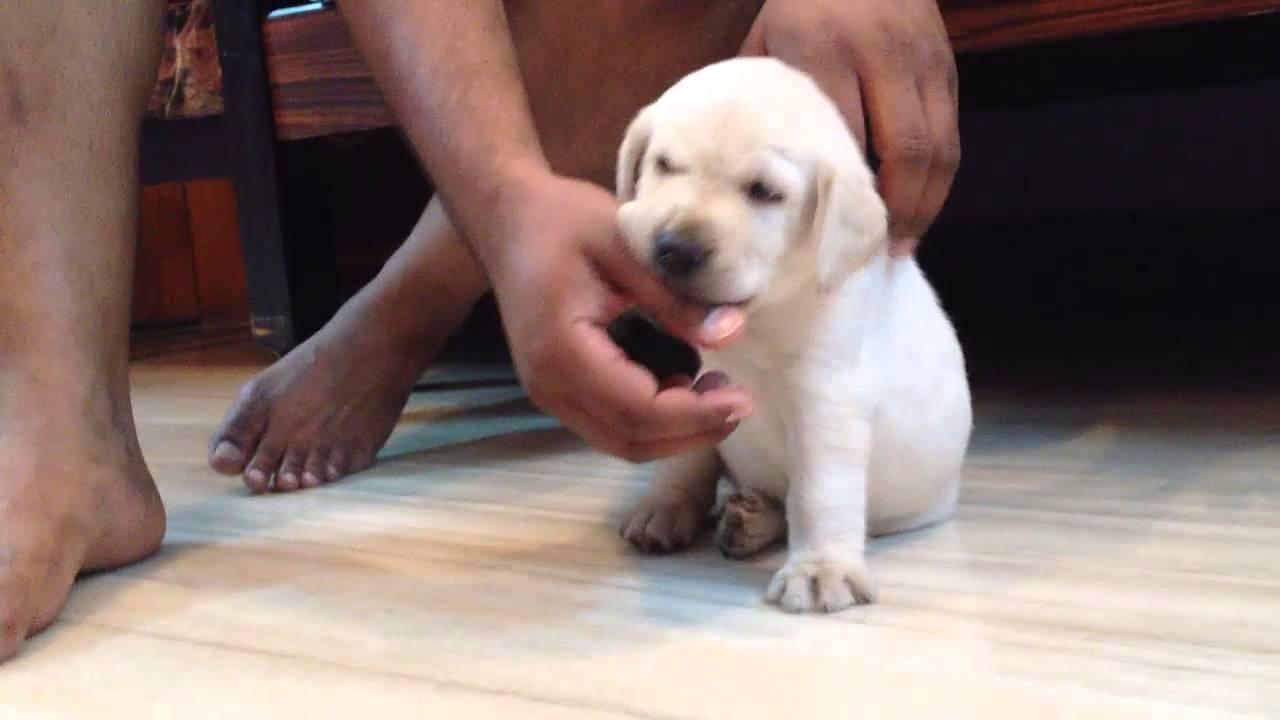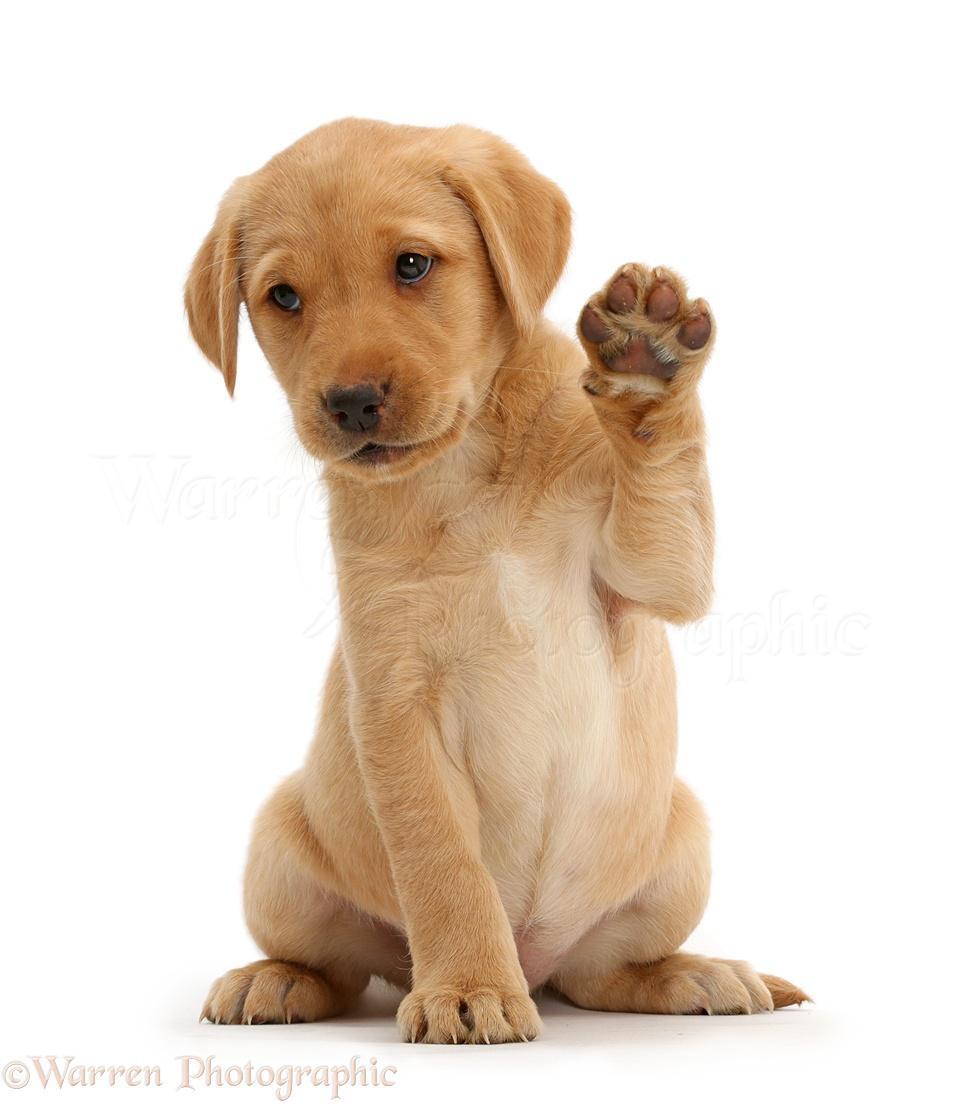The first image is the image on the left, the second image is the image on the right. For the images shown, is this caption "An image contains one black puppy to the left of one tan puppy, and contains only two puppies." true? Answer yes or no. No. 